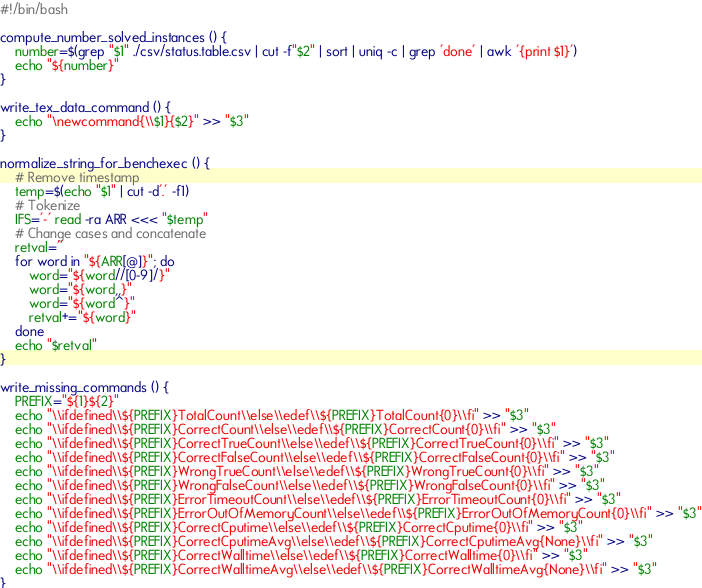Convert code to text. <code><loc_0><loc_0><loc_500><loc_500><_Bash_>#!/bin/bash

compute_number_solved_instances () {
    number=$(grep "$1" ./csv/status.table.csv | cut -f"$2" | sort | uniq -c | grep 'done' | awk '{print $1}')
    echo "${number}"
}

write_tex_data_command () {
    echo "\newcommand{\\$1}{$2}" >> "$3"
}

normalize_string_for_benchexec () {
    # Remove timestamp
    temp=$(echo "$1" | cut -d'.' -f1)
    # Tokenize
    IFS='-' read -ra ARR <<< "$temp"
    # Change cases and concatenate
    retval=''
    for word in "${ARR[@]}"; do
        word="${word//[0-9]/}"
        word="${word,,}"
        word="${word^}"
        retval+="${word}"
    done
    echo "$retval"
}

write_missing_commands () {
    PREFIX="${1}${2}"
    echo "\\ifdefined\\${PREFIX}TotalCount\\else\\edef\\${PREFIX}TotalCount{0}\\fi" >> "$3"
    echo "\\ifdefined\\${PREFIX}CorrectCount\\else\\edef\\${PREFIX}CorrectCount{0}\\fi" >> "$3"
    echo "\\ifdefined\\${PREFIX}CorrectTrueCount\\else\\edef\\${PREFIX}CorrectTrueCount{0}\\fi" >> "$3"
    echo "\\ifdefined\\${PREFIX}CorrectFalseCount\\else\\edef\\${PREFIX}CorrectFalseCount{0}\\fi" >> "$3"
    echo "\\ifdefined\\${PREFIX}WrongTrueCount\\else\\edef\\${PREFIX}WrongTrueCount{0}\\fi" >> "$3"
    echo "\\ifdefined\\${PREFIX}WrongFalseCount\\else\\edef\\${PREFIX}WrongFalseCount{0}\\fi" >> "$3"
    echo "\\ifdefined\\${PREFIX}ErrorTimeoutCount\\else\\edef\\${PREFIX}ErrorTimeoutCount{0}\\fi" >> "$3"
    echo "\\ifdefined\\${PREFIX}ErrorOutOfMemoryCount\\else\\edef\\${PREFIX}ErrorOutOfMemoryCount{0}\\fi" >> "$3"
    echo "\\ifdefined\\${PREFIX}CorrectCputime\\else\\edef\\${PREFIX}CorrectCputime{0}\\fi" >> "$3"
    echo "\\ifdefined\\${PREFIX}CorrectCputimeAvg\\else\\edef\\${PREFIX}CorrectCputimeAvg{None}\\fi" >> "$3"
    echo "\\ifdefined\\${PREFIX}CorrectWalltime\\else\\edef\\${PREFIX}CorrectWalltime{0}\\fi" >> "$3"
    echo "\\ifdefined\\${PREFIX}CorrectWalltimeAvg\\else\\edef\\${PREFIX}CorrectWalltimeAvg{None}\\fi" >> "$3"
}
</code> 